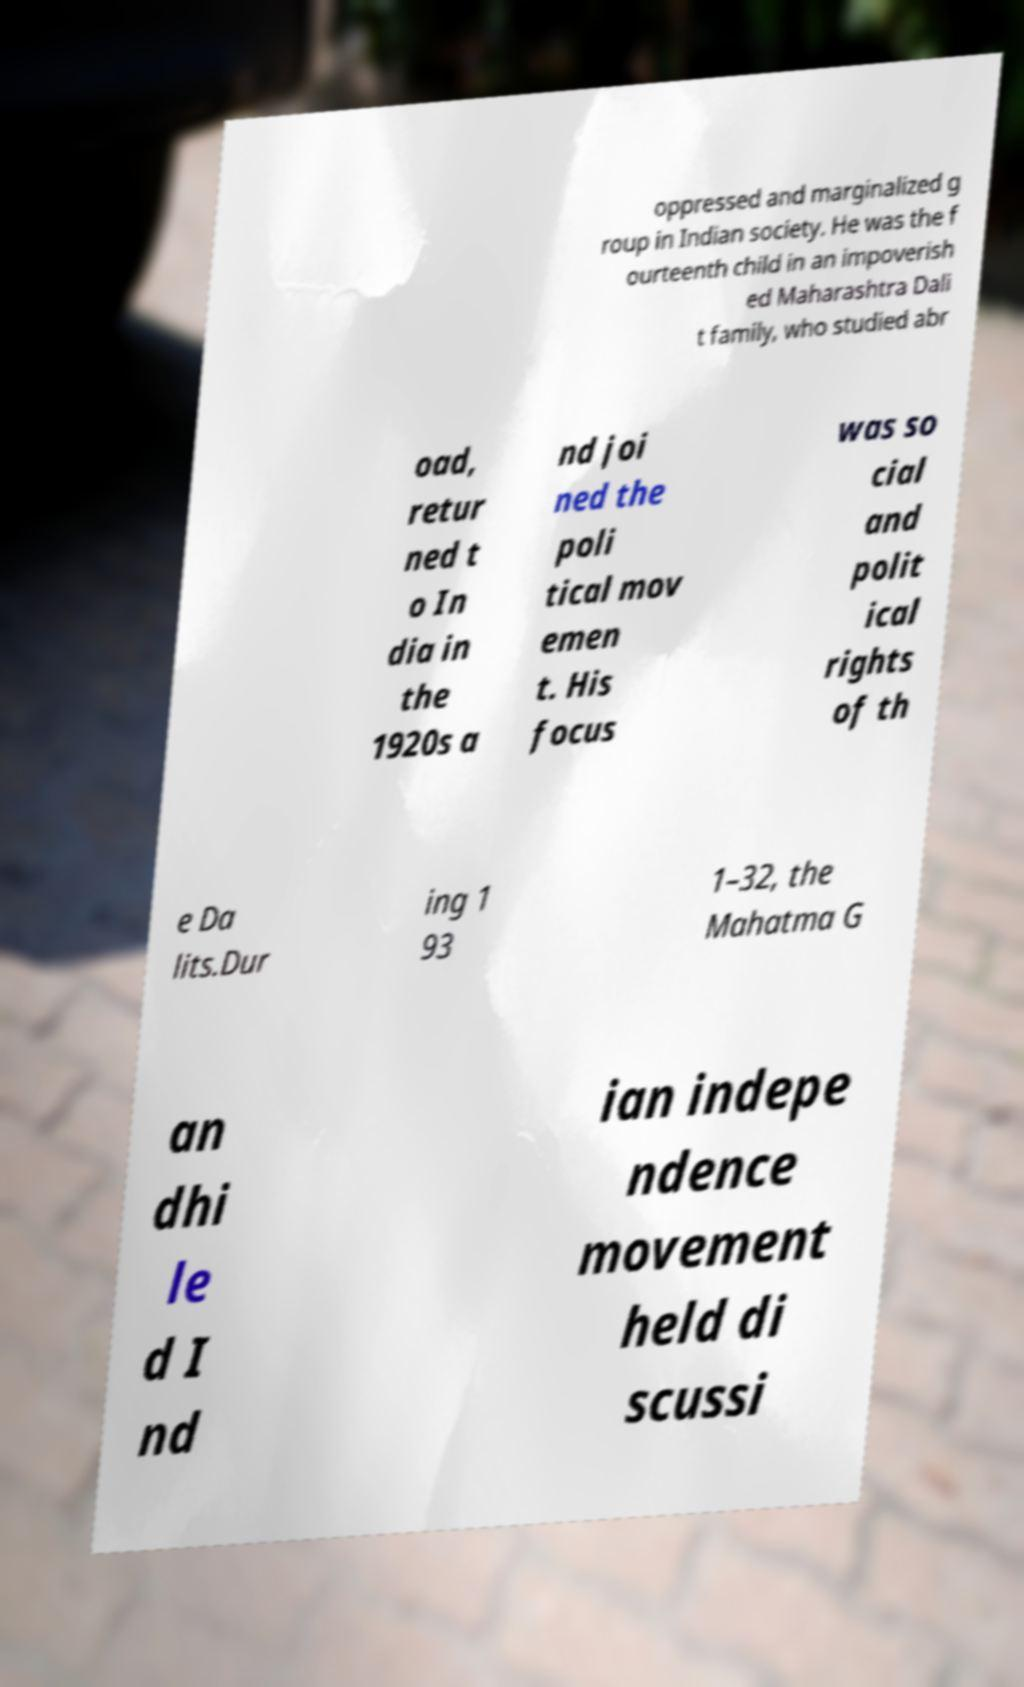For documentation purposes, I need the text within this image transcribed. Could you provide that? oppressed and marginalized g roup in Indian society. He was the f ourteenth child in an impoverish ed Maharashtra Dali t family, who studied abr oad, retur ned t o In dia in the 1920s a nd joi ned the poli tical mov emen t. His focus was so cial and polit ical rights of th e Da lits.Dur ing 1 93 1–32, the Mahatma G an dhi le d I nd ian indepe ndence movement held di scussi 